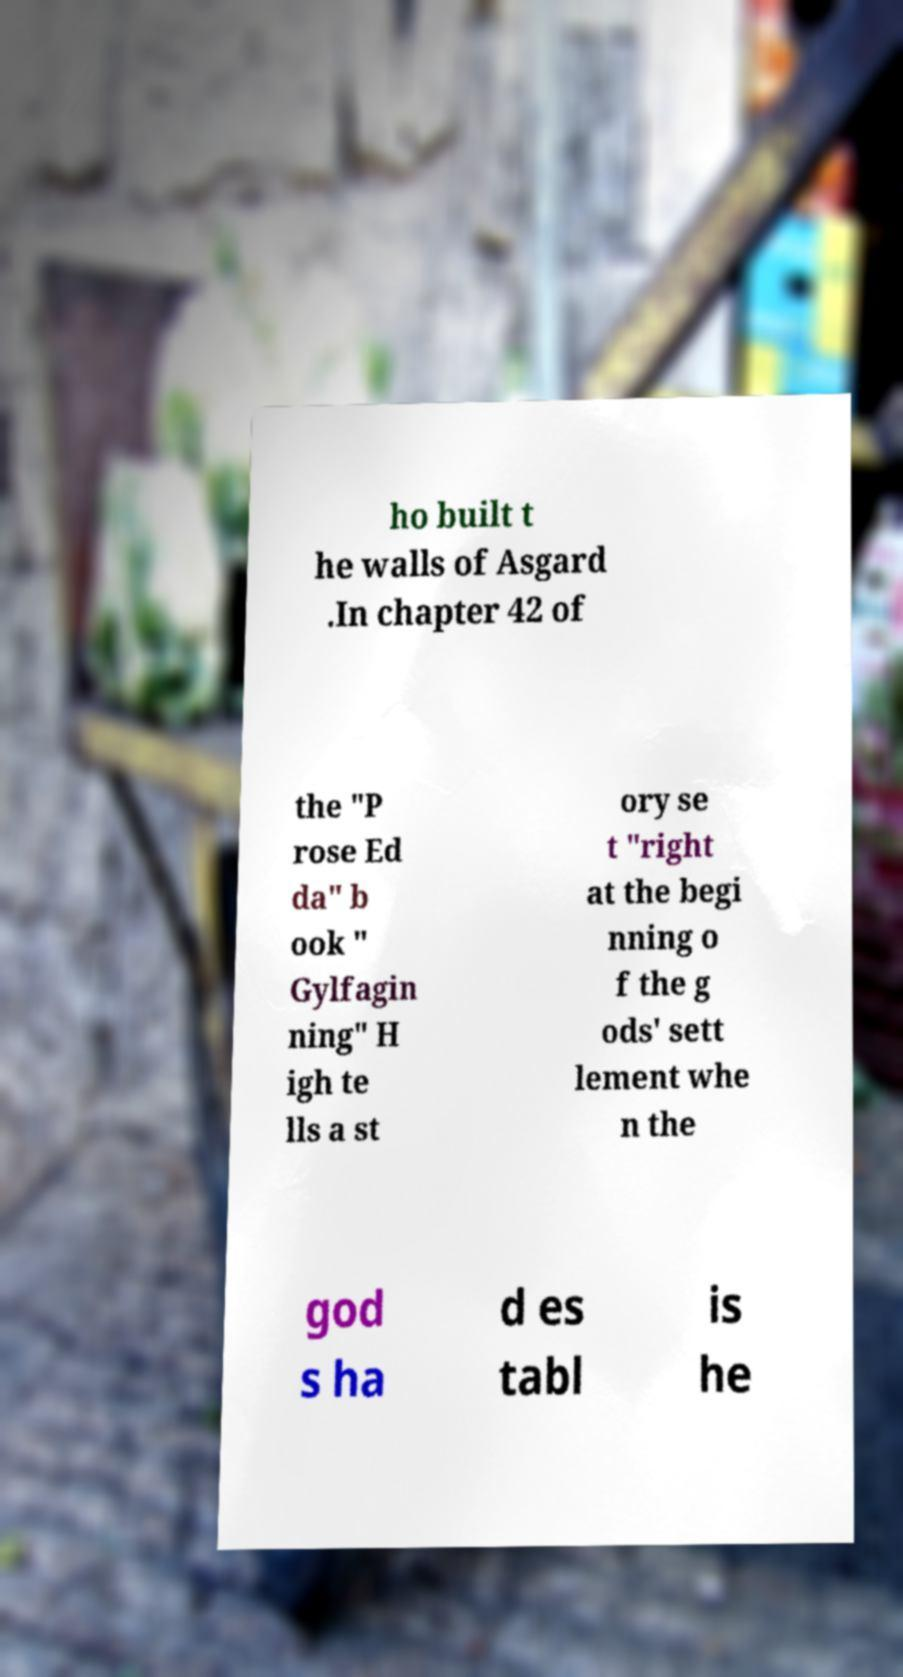Could you extract and type out the text from this image? ho built t he walls of Asgard .In chapter 42 of the "P rose Ed da" b ook " Gylfagin ning" H igh te lls a st ory se t "right at the begi nning o f the g ods' sett lement whe n the god s ha d es tabl is he 